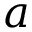<formula> <loc_0><loc_0><loc_500><loc_500>a</formula> 